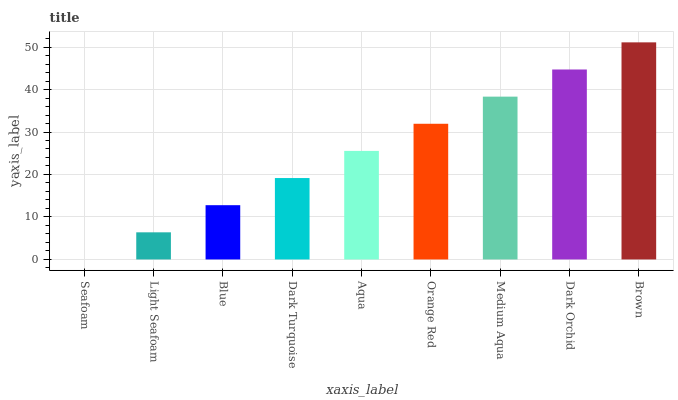Is Seafoam the minimum?
Answer yes or no. Yes. Is Brown the maximum?
Answer yes or no. Yes. Is Light Seafoam the minimum?
Answer yes or no. No. Is Light Seafoam the maximum?
Answer yes or no. No. Is Light Seafoam greater than Seafoam?
Answer yes or no. Yes. Is Seafoam less than Light Seafoam?
Answer yes or no. Yes. Is Seafoam greater than Light Seafoam?
Answer yes or no. No. Is Light Seafoam less than Seafoam?
Answer yes or no. No. Is Aqua the high median?
Answer yes or no. Yes. Is Aqua the low median?
Answer yes or no. Yes. Is Orange Red the high median?
Answer yes or no. No. Is Blue the low median?
Answer yes or no. No. 